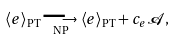<formula> <loc_0><loc_0><loc_500><loc_500>\langle e \rangle _ { \text {PT} } \underset { \text {NP} } { \longrightarrow } \langle e \rangle _ { \text {PT} } + c _ { e } \mathcal { A } ,</formula> 